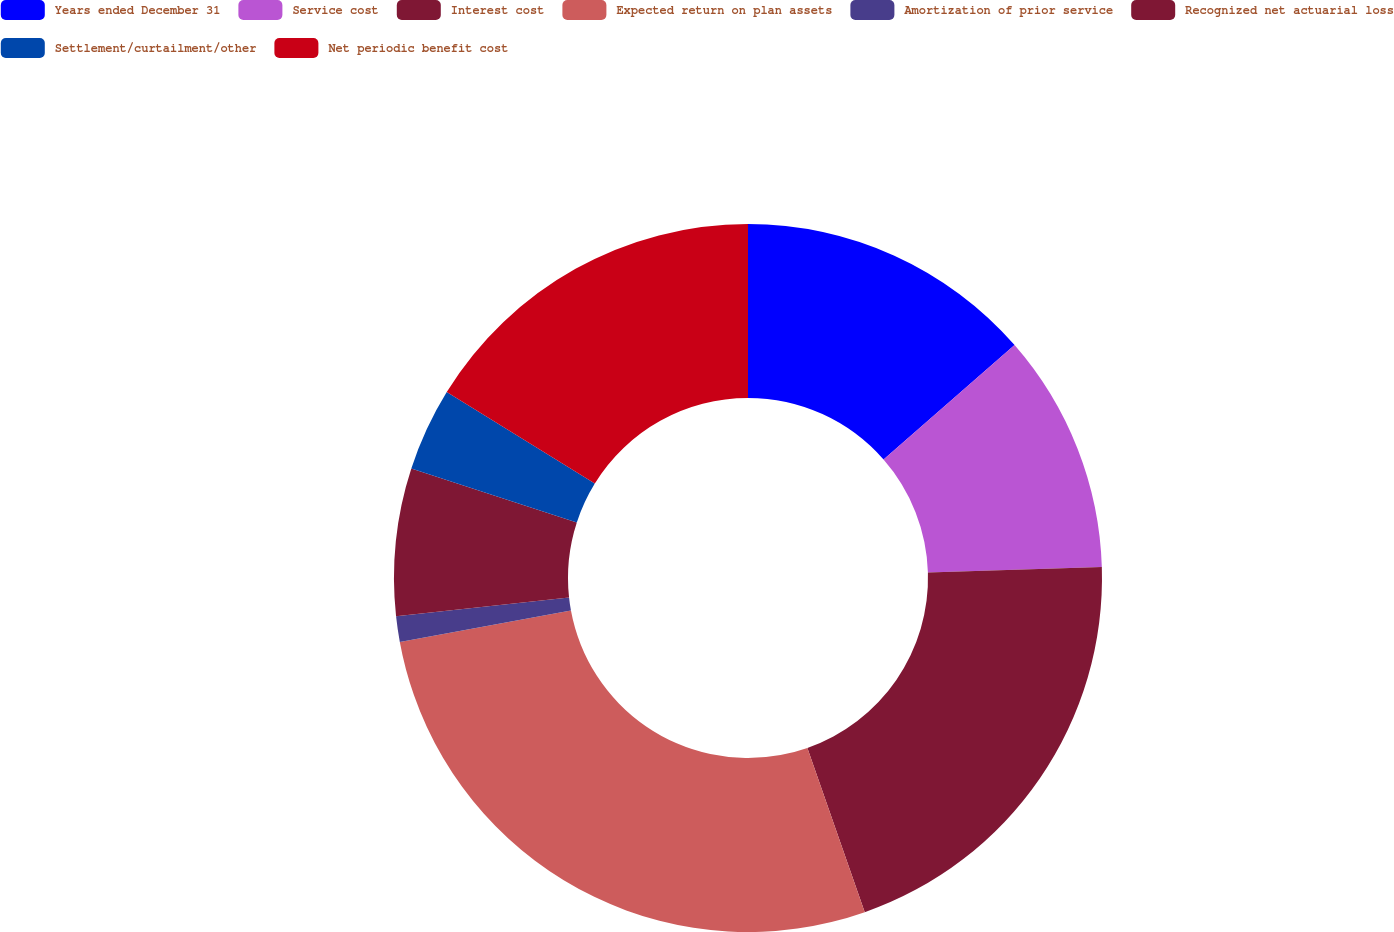Convert chart. <chart><loc_0><loc_0><loc_500><loc_500><pie_chart><fcel>Years ended December 31<fcel>Service cost<fcel>Interest cost<fcel>Expected return on plan assets<fcel>Amortization of prior service<fcel>Recognized net actuarial loss<fcel>Settlement/curtailment/other<fcel>Net periodic benefit cost<nl><fcel>13.57%<fcel>10.94%<fcel>20.14%<fcel>27.46%<fcel>1.17%<fcel>6.72%<fcel>3.8%<fcel>16.2%<nl></chart> 